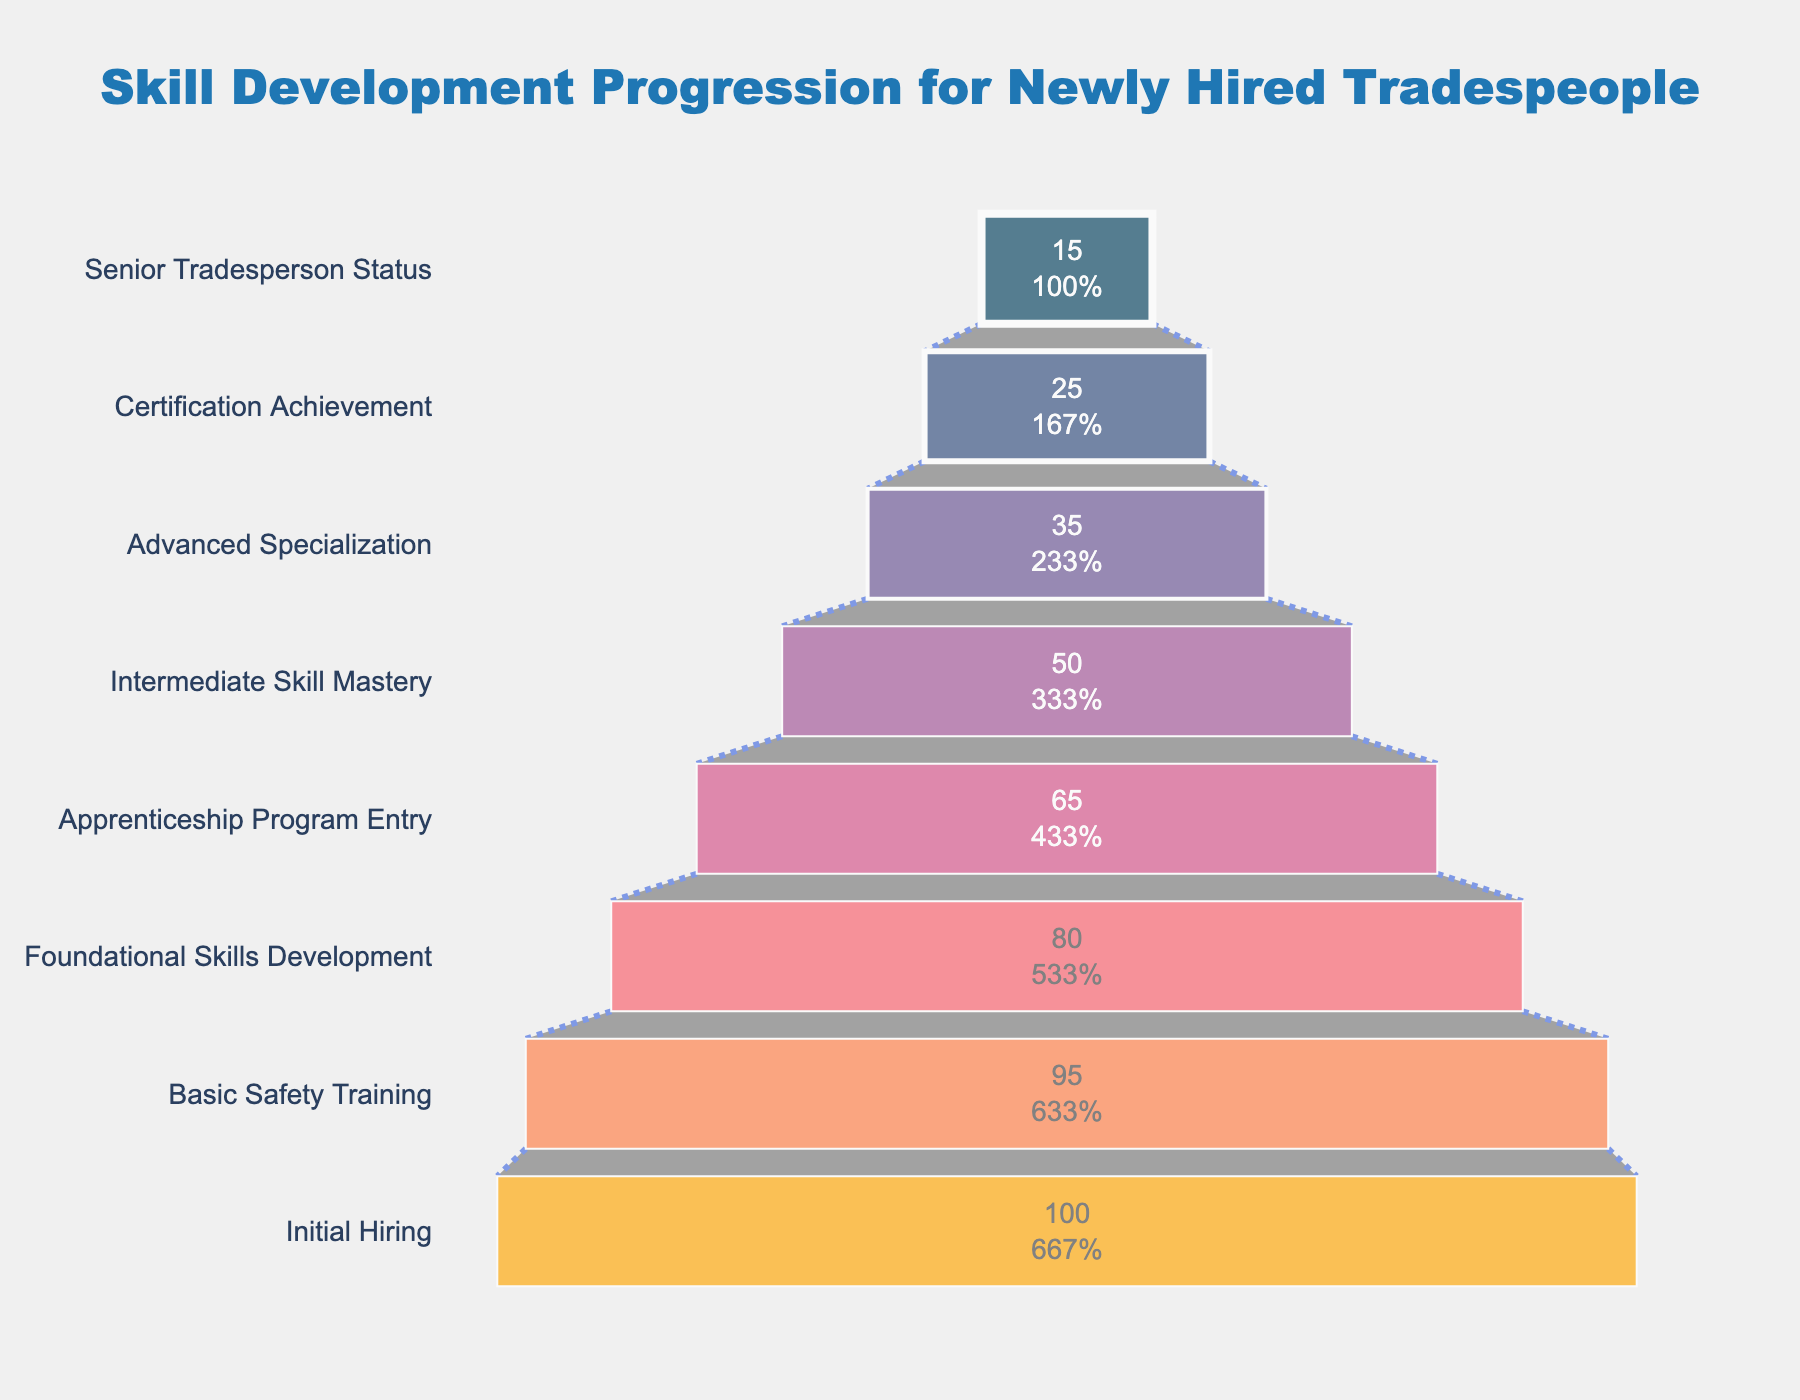What is the title of the funnel chart? The title is displayed at the top center of the chart. It reads: "Skill Development Progression for Newly Hired Tradespeople".
Answer: Skill Development Progression for Newly Hired Tradespeople What is the number of employees at the Initial Hiring stage? The number of employees is indicated inside the funnel chart at the Initial Hiring stage. It shows 100 employees.
Answer: 100 Which stage sees the largest drop in the number of employees from the previous stage? To find the largest drop, we compute the differences between consecutive stages. The drop between Foundational Skills Development (80) and Apprenticeship Program Entry (65) is the largest at 15 employees.
Answer: Foundational Skills Development to Apprenticeship Program Entry How many employees achieve Certification Achievement? The number of employees achieving Certification Achievement is displayed inside the funnel chart at that stage. It shows 25 employees.
Answer: 25 What is the difference in the number of employees between Basic Safety Training and Advanced Specialization? Subtract the number of employees at Advanced Specialization (35) from the number at Basic Safety Training (95). The difference is 95 - 35 = 60.
Answer: 60 How many more employees are there in the Intermediate Skill Mastery stage compared to the Senior Tradesperson Status stage? The number of employees in Intermediate Skill Mastery is 50, and in Senior Tradesperson Status is 15. The difference is 50 - 15 = 35.
Answer: 35 What percentage of the initial hires reach Advanced Specialization? The number of employees reaching Advanced Specialization is 35 out of the initial 100 hires. Calculating the percentage, (35/100) * 100 = 35%.
Answer: 35% Which stage has the smallest number of employees? The funnel chart shows that the stage with the smallest number of employees is Senior Tradesperson Status, with 15 employees.
Answer: Senior Tradesperson Status How many stages are there in the skill development funnel? Counting all stages listed in the funnel chart from Initial Hiring to Senior Tradesperson Status, there are 8 stages.
Answer: 8 